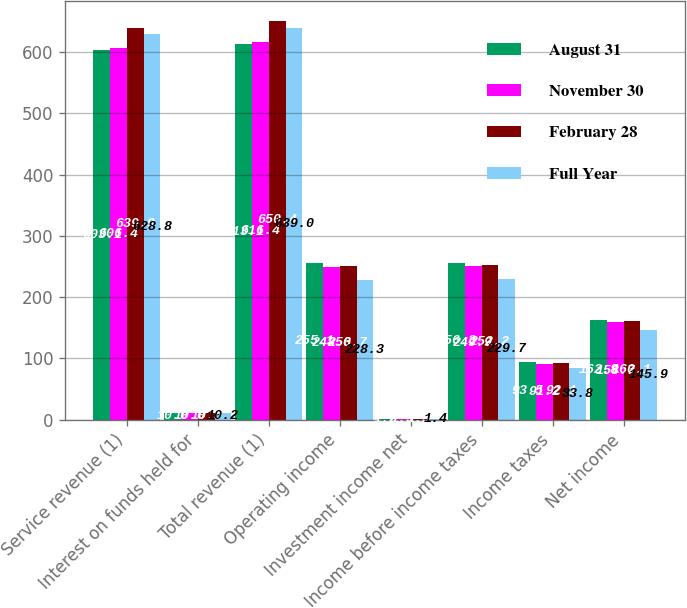Convert chart. <chart><loc_0><loc_0><loc_500><loc_500><stacked_bar_chart><ecel><fcel>Service revenue (1)<fcel>Interest on funds held for<fcel>Total revenue (1)<fcel>Operating income<fcel>Investment income net<fcel>Income before income taxes<fcel>Income taxes<fcel>Net income<nl><fcel>August 31<fcel>603.1<fcel>10<fcel>613.1<fcel>255.1<fcel>1.2<fcel>256.3<fcel>93.5<fcel>162.8<nl><fcel>November 30<fcel>606.4<fcel>10<fcel>616.4<fcel>248.6<fcel>1.3<fcel>249.9<fcel>91.2<fcel>158.7<nl><fcel>February 28<fcel>639.9<fcel>10.5<fcel>650.4<fcel>250.7<fcel>1.5<fcel>252.2<fcel>92.1<fcel>160.1<nl><fcel>Full Year<fcel>628.8<fcel>10.2<fcel>639<fcel>228.3<fcel>1.4<fcel>229.7<fcel>83.8<fcel>145.9<nl></chart> 